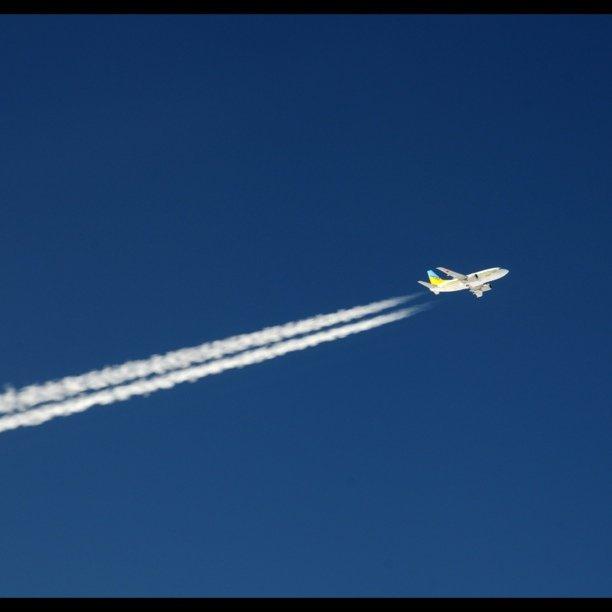What colors are the plane's tail?
Short answer required. White. Is the sun setting?
Keep it brief. No. Where is the plane?
Keep it brief. Sky. Is the sky cloudy?
Answer briefly. No. Is the sky clear?
Write a very short answer. Yes. How is the sky?
Write a very short answer. Clear. What nation does this plane come from?
Write a very short answer. Usa. Is the plane polluting the air?
Answer briefly. Yes. 